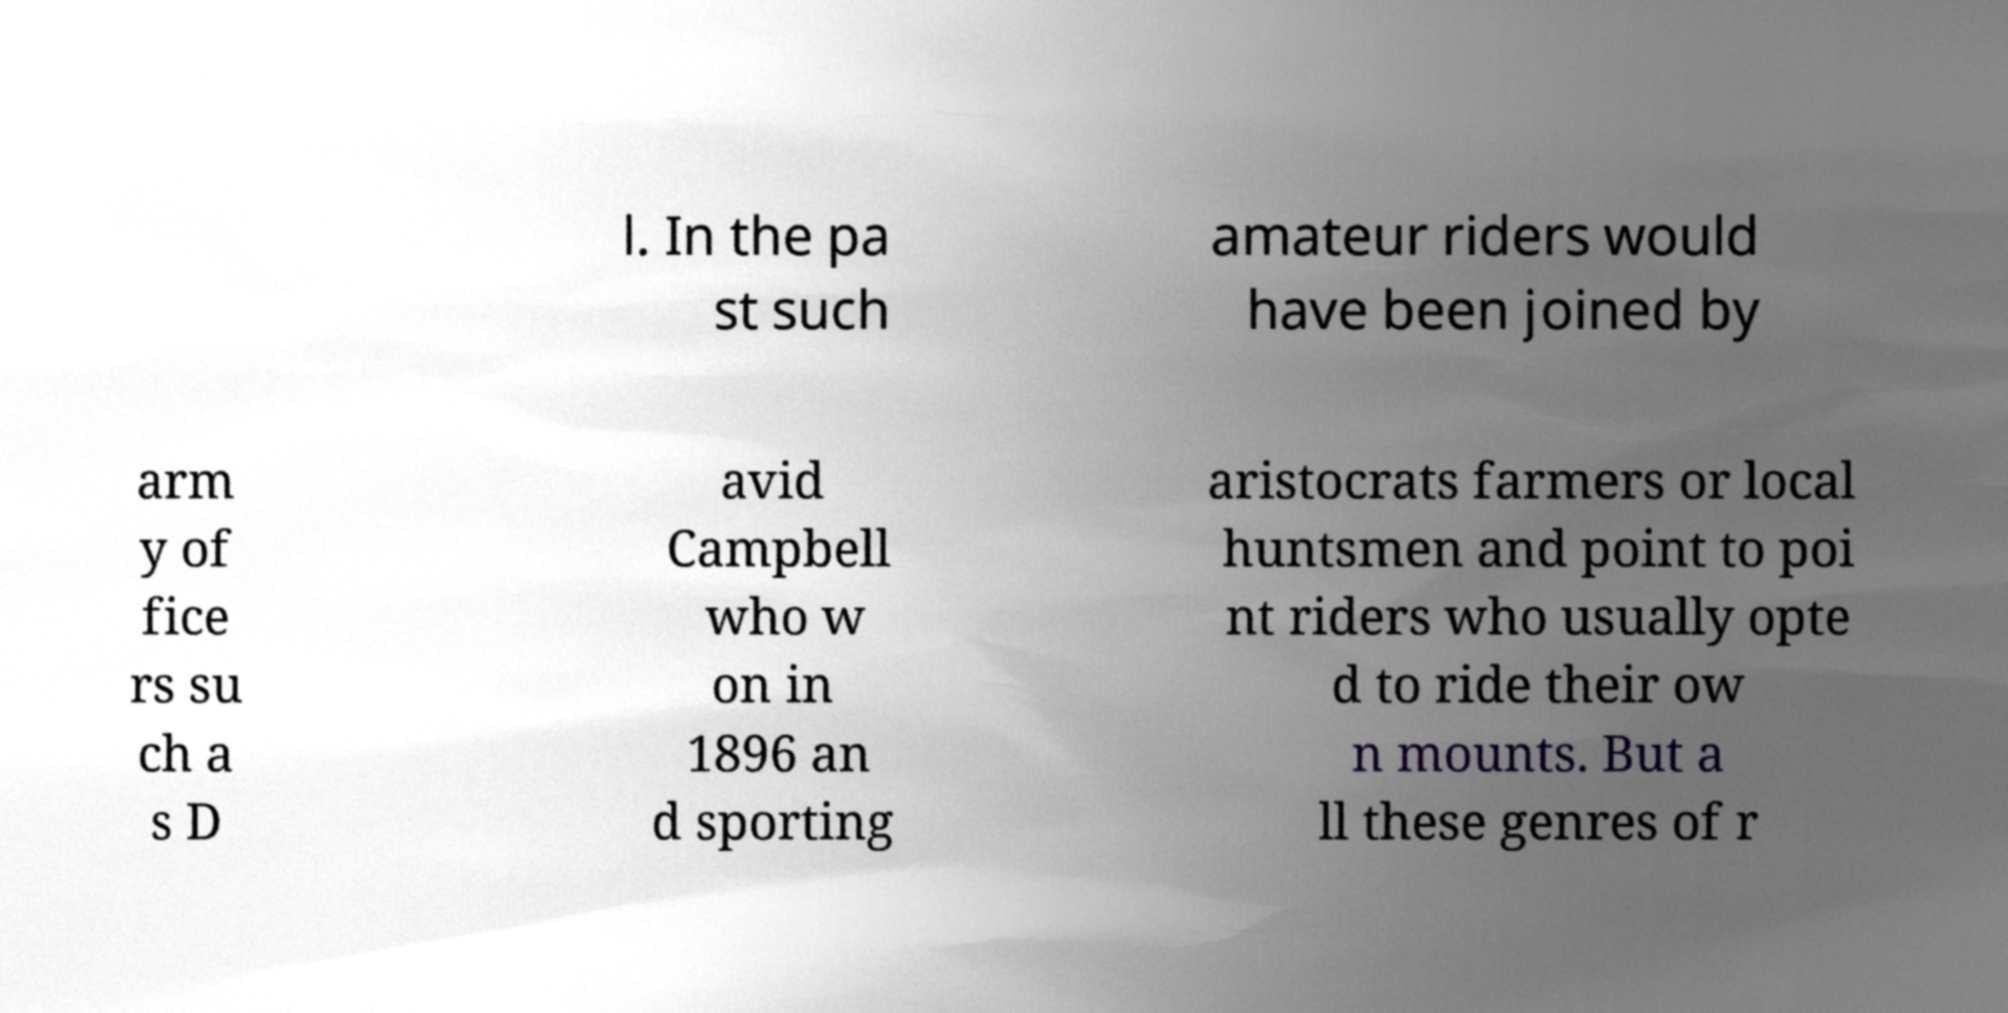For documentation purposes, I need the text within this image transcribed. Could you provide that? l. In the pa st such amateur riders would have been joined by arm y of fice rs su ch a s D avid Campbell who w on in 1896 an d sporting aristocrats farmers or local huntsmen and point to poi nt riders who usually opte d to ride their ow n mounts. But a ll these genres of r 